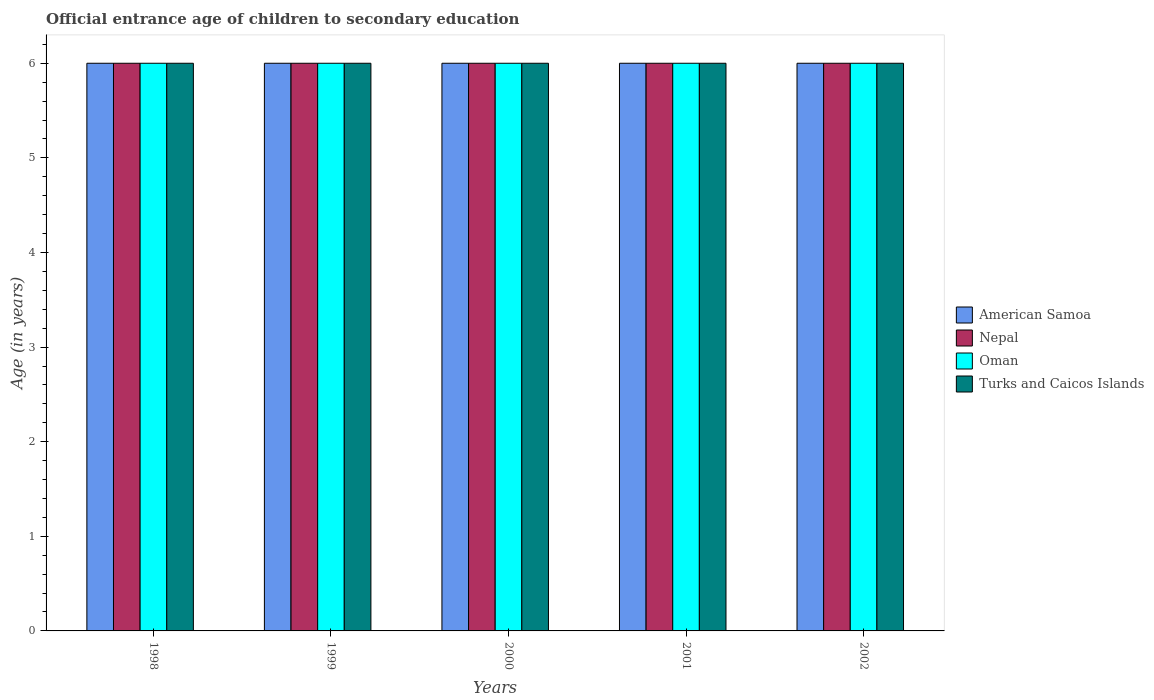How many groups of bars are there?
Make the answer very short. 5. Are the number of bars per tick equal to the number of legend labels?
Offer a terse response. Yes. Are the number of bars on each tick of the X-axis equal?
Provide a succinct answer. Yes. How many bars are there on the 1st tick from the left?
Provide a succinct answer. 4. In how many cases, is the number of bars for a given year not equal to the number of legend labels?
Make the answer very short. 0. What is the secondary school starting age of children in Oman in 1999?
Give a very brief answer. 6. Across all years, what is the maximum secondary school starting age of children in American Samoa?
Keep it short and to the point. 6. Across all years, what is the minimum secondary school starting age of children in American Samoa?
Provide a short and direct response. 6. In which year was the secondary school starting age of children in Turks and Caicos Islands maximum?
Offer a terse response. 1998. In which year was the secondary school starting age of children in Turks and Caicos Islands minimum?
Give a very brief answer. 1998. What is the average secondary school starting age of children in Turks and Caicos Islands per year?
Your response must be concise. 6. In the year 2000, what is the difference between the secondary school starting age of children in American Samoa and secondary school starting age of children in Turks and Caicos Islands?
Ensure brevity in your answer.  0. In how many years, is the secondary school starting age of children in American Samoa greater than 5.8 years?
Your response must be concise. 5. In how many years, is the secondary school starting age of children in American Samoa greater than the average secondary school starting age of children in American Samoa taken over all years?
Your answer should be very brief. 0. What does the 1st bar from the left in 2002 represents?
Ensure brevity in your answer.  American Samoa. What does the 2nd bar from the right in 2000 represents?
Give a very brief answer. Oman. What is the difference between two consecutive major ticks on the Y-axis?
Your answer should be compact. 1. Are the values on the major ticks of Y-axis written in scientific E-notation?
Your answer should be compact. No. Where does the legend appear in the graph?
Your answer should be compact. Center right. How many legend labels are there?
Provide a succinct answer. 4. How are the legend labels stacked?
Your answer should be compact. Vertical. What is the title of the graph?
Make the answer very short. Official entrance age of children to secondary education. What is the label or title of the Y-axis?
Offer a very short reply. Age (in years). What is the Age (in years) of Nepal in 1998?
Offer a very short reply. 6. What is the Age (in years) of Oman in 1998?
Give a very brief answer. 6. What is the Age (in years) of American Samoa in 1999?
Make the answer very short. 6. What is the Age (in years) of Oman in 1999?
Keep it short and to the point. 6. What is the Age (in years) of Turks and Caicos Islands in 1999?
Make the answer very short. 6. What is the Age (in years) of American Samoa in 2000?
Your answer should be compact. 6. What is the Age (in years) in Turks and Caicos Islands in 2000?
Keep it short and to the point. 6. What is the Age (in years) of Nepal in 2001?
Your answer should be compact. 6. What is the Age (in years) of Turks and Caicos Islands in 2001?
Provide a succinct answer. 6. What is the Age (in years) of Nepal in 2002?
Ensure brevity in your answer.  6. Across all years, what is the maximum Age (in years) of Nepal?
Your answer should be very brief. 6. Across all years, what is the maximum Age (in years) in Oman?
Keep it short and to the point. 6. Across all years, what is the minimum Age (in years) of Turks and Caicos Islands?
Provide a short and direct response. 6. What is the total Age (in years) in Nepal in the graph?
Make the answer very short. 30. What is the total Age (in years) in Oman in the graph?
Your answer should be very brief. 30. What is the total Age (in years) in Turks and Caicos Islands in the graph?
Make the answer very short. 30. What is the difference between the Age (in years) of American Samoa in 1998 and that in 1999?
Give a very brief answer. 0. What is the difference between the Age (in years) in Nepal in 1998 and that in 1999?
Keep it short and to the point. 0. What is the difference between the Age (in years) of American Samoa in 1998 and that in 2000?
Provide a short and direct response. 0. What is the difference between the Age (in years) of Nepal in 1998 and that in 2000?
Provide a short and direct response. 0. What is the difference between the Age (in years) of Oman in 1998 and that in 2000?
Give a very brief answer. 0. What is the difference between the Age (in years) of American Samoa in 1998 and that in 2001?
Offer a very short reply. 0. What is the difference between the Age (in years) of Nepal in 1998 and that in 2001?
Provide a succinct answer. 0. What is the difference between the Age (in years) in Oman in 1998 and that in 2001?
Ensure brevity in your answer.  0. What is the difference between the Age (in years) in Turks and Caicos Islands in 1998 and that in 2001?
Provide a succinct answer. 0. What is the difference between the Age (in years) in American Samoa in 1998 and that in 2002?
Provide a succinct answer. 0. What is the difference between the Age (in years) in Nepal in 1998 and that in 2002?
Keep it short and to the point. 0. What is the difference between the Age (in years) of Turks and Caicos Islands in 1998 and that in 2002?
Your answer should be very brief. 0. What is the difference between the Age (in years) in American Samoa in 1999 and that in 2000?
Your answer should be very brief. 0. What is the difference between the Age (in years) in Nepal in 1999 and that in 2000?
Your answer should be compact. 0. What is the difference between the Age (in years) of Oman in 1999 and that in 2000?
Ensure brevity in your answer.  0. What is the difference between the Age (in years) of Nepal in 1999 and that in 2001?
Keep it short and to the point. 0. What is the difference between the Age (in years) of Oman in 1999 and that in 2001?
Keep it short and to the point. 0. What is the difference between the Age (in years) in American Samoa in 1999 and that in 2002?
Offer a terse response. 0. What is the difference between the Age (in years) of Oman in 1999 and that in 2002?
Give a very brief answer. 0. What is the difference between the Age (in years) of Turks and Caicos Islands in 1999 and that in 2002?
Your response must be concise. 0. What is the difference between the Age (in years) of Nepal in 2000 and that in 2001?
Provide a short and direct response. 0. What is the difference between the Age (in years) in American Samoa in 2000 and that in 2002?
Keep it short and to the point. 0. What is the difference between the Age (in years) of Nepal in 2000 and that in 2002?
Your answer should be very brief. 0. What is the difference between the Age (in years) in Oman in 2000 and that in 2002?
Ensure brevity in your answer.  0. What is the difference between the Age (in years) in Turks and Caicos Islands in 2000 and that in 2002?
Your answer should be very brief. 0. What is the difference between the Age (in years) of American Samoa in 2001 and that in 2002?
Your answer should be very brief. 0. What is the difference between the Age (in years) in Nepal in 2001 and that in 2002?
Ensure brevity in your answer.  0. What is the difference between the Age (in years) in American Samoa in 1998 and the Age (in years) in Nepal in 1999?
Offer a very short reply. 0. What is the difference between the Age (in years) in American Samoa in 1998 and the Age (in years) in Oman in 1999?
Your response must be concise. 0. What is the difference between the Age (in years) of American Samoa in 1998 and the Age (in years) of Turks and Caicos Islands in 1999?
Provide a short and direct response. 0. What is the difference between the Age (in years) of Nepal in 1998 and the Age (in years) of Oman in 1999?
Provide a succinct answer. 0. What is the difference between the Age (in years) in American Samoa in 1998 and the Age (in years) in Nepal in 2000?
Offer a very short reply. 0. What is the difference between the Age (in years) in Oman in 1998 and the Age (in years) in Turks and Caicos Islands in 2000?
Provide a succinct answer. 0. What is the difference between the Age (in years) in American Samoa in 1998 and the Age (in years) in Oman in 2001?
Give a very brief answer. 0. What is the difference between the Age (in years) in American Samoa in 1998 and the Age (in years) in Turks and Caicos Islands in 2001?
Ensure brevity in your answer.  0. What is the difference between the Age (in years) in Nepal in 1998 and the Age (in years) in Oman in 2001?
Provide a succinct answer. 0. What is the difference between the Age (in years) in Nepal in 1998 and the Age (in years) in Turks and Caicos Islands in 2001?
Offer a terse response. 0. What is the difference between the Age (in years) of American Samoa in 1998 and the Age (in years) of Oman in 2002?
Make the answer very short. 0. What is the difference between the Age (in years) of American Samoa in 1998 and the Age (in years) of Turks and Caicos Islands in 2002?
Ensure brevity in your answer.  0. What is the difference between the Age (in years) of Nepal in 1998 and the Age (in years) of Turks and Caicos Islands in 2002?
Provide a short and direct response. 0. What is the difference between the Age (in years) of American Samoa in 1999 and the Age (in years) of Oman in 2000?
Provide a succinct answer. 0. What is the difference between the Age (in years) of American Samoa in 1999 and the Age (in years) of Turks and Caicos Islands in 2000?
Your answer should be very brief. 0. What is the difference between the Age (in years) in American Samoa in 1999 and the Age (in years) in Nepal in 2001?
Your answer should be compact. 0. What is the difference between the Age (in years) in American Samoa in 1999 and the Age (in years) in Turks and Caicos Islands in 2001?
Provide a short and direct response. 0. What is the difference between the Age (in years) in Oman in 1999 and the Age (in years) in Turks and Caicos Islands in 2001?
Offer a terse response. 0. What is the difference between the Age (in years) in American Samoa in 1999 and the Age (in years) in Nepal in 2002?
Give a very brief answer. 0. What is the difference between the Age (in years) in American Samoa in 1999 and the Age (in years) in Turks and Caicos Islands in 2002?
Your answer should be very brief. 0. What is the difference between the Age (in years) in Nepal in 1999 and the Age (in years) in Turks and Caicos Islands in 2002?
Make the answer very short. 0. What is the difference between the Age (in years) in American Samoa in 2000 and the Age (in years) in Nepal in 2001?
Your answer should be compact. 0. What is the difference between the Age (in years) in American Samoa in 2000 and the Age (in years) in Oman in 2001?
Provide a short and direct response. 0. What is the difference between the Age (in years) of Nepal in 2000 and the Age (in years) of Oman in 2001?
Keep it short and to the point. 0. What is the difference between the Age (in years) of American Samoa in 2000 and the Age (in years) of Nepal in 2002?
Offer a very short reply. 0. What is the difference between the Age (in years) in American Samoa in 2000 and the Age (in years) in Turks and Caicos Islands in 2002?
Offer a terse response. 0. What is the difference between the Age (in years) in Nepal in 2000 and the Age (in years) in Turks and Caicos Islands in 2002?
Make the answer very short. 0. What is the difference between the Age (in years) of Oman in 2000 and the Age (in years) of Turks and Caicos Islands in 2002?
Ensure brevity in your answer.  0. What is the difference between the Age (in years) in American Samoa in 2001 and the Age (in years) in Nepal in 2002?
Provide a succinct answer. 0. What is the difference between the Age (in years) of American Samoa in 2001 and the Age (in years) of Turks and Caicos Islands in 2002?
Offer a very short reply. 0. What is the difference between the Age (in years) of Oman in 2001 and the Age (in years) of Turks and Caicos Islands in 2002?
Your answer should be compact. 0. What is the average Age (in years) in Nepal per year?
Provide a short and direct response. 6. What is the average Age (in years) in Oman per year?
Your answer should be compact. 6. What is the average Age (in years) in Turks and Caicos Islands per year?
Ensure brevity in your answer.  6. In the year 1998, what is the difference between the Age (in years) in American Samoa and Age (in years) in Nepal?
Make the answer very short. 0. In the year 1998, what is the difference between the Age (in years) in American Samoa and Age (in years) in Turks and Caicos Islands?
Offer a terse response. 0. In the year 1998, what is the difference between the Age (in years) in Nepal and Age (in years) in Oman?
Ensure brevity in your answer.  0. In the year 1998, what is the difference between the Age (in years) in Oman and Age (in years) in Turks and Caicos Islands?
Make the answer very short. 0. In the year 1999, what is the difference between the Age (in years) of Nepal and Age (in years) of Oman?
Give a very brief answer. 0. In the year 1999, what is the difference between the Age (in years) of Nepal and Age (in years) of Turks and Caicos Islands?
Make the answer very short. 0. In the year 1999, what is the difference between the Age (in years) in Oman and Age (in years) in Turks and Caicos Islands?
Provide a short and direct response. 0. In the year 2000, what is the difference between the Age (in years) in American Samoa and Age (in years) in Oman?
Your response must be concise. 0. In the year 2001, what is the difference between the Age (in years) of American Samoa and Age (in years) of Nepal?
Provide a succinct answer. 0. In the year 2001, what is the difference between the Age (in years) in Nepal and Age (in years) in Oman?
Provide a short and direct response. 0. In the year 2001, what is the difference between the Age (in years) in Nepal and Age (in years) in Turks and Caicos Islands?
Your answer should be very brief. 0. In the year 2001, what is the difference between the Age (in years) in Oman and Age (in years) in Turks and Caicos Islands?
Provide a short and direct response. 0. In the year 2002, what is the difference between the Age (in years) of American Samoa and Age (in years) of Nepal?
Provide a succinct answer. 0. In the year 2002, what is the difference between the Age (in years) in American Samoa and Age (in years) in Oman?
Give a very brief answer. 0. In the year 2002, what is the difference between the Age (in years) of Oman and Age (in years) of Turks and Caicos Islands?
Make the answer very short. 0. What is the ratio of the Age (in years) of Nepal in 1998 to that in 1999?
Make the answer very short. 1. What is the ratio of the Age (in years) in Oman in 1998 to that in 1999?
Provide a short and direct response. 1. What is the ratio of the Age (in years) of American Samoa in 1998 to that in 2001?
Your answer should be very brief. 1. What is the ratio of the Age (in years) of American Samoa in 1998 to that in 2002?
Your answer should be very brief. 1. What is the ratio of the Age (in years) of Oman in 1998 to that in 2002?
Ensure brevity in your answer.  1. What is the ratio of the Age (in years) in Turks and Caicos Islands in 1998 to that in 2002?
Make the answer very short. 1. What is the ratio of the Age (in years) in American Samoa in 1999 to that in 2000?
Offer a very short reply. 1. What is the ratio of the Age (in years) of Oman in 1999 to that in 2000?
Offer a very short reply. 1. What is the ratio of the Age (in years) of American Samoa in 1999 to that in 2001?
Your response must be concise. 1. What is the ratio of the Age (in years) in Nepal in 1999 to that in 2001?
Your response must be concise. 1. What is the ratio of the Age (in years) in Turks and Caicos Islands in 1999 to that in 2001?
Ensure brevity in your answer.  1. What is the ratio of the Age (in years) of American Samoa in 1999 to that in 2002?
Make the answer very short. 1. What is the ratio of the Age (in years) in Turks and Caicos Islands in 1999 to that in 2002?
Offer a terse response. 1. What is the ratio of the Age (in years) in American Samoa in 2000 to that in 2001?
Offer a very short reply. 1. What is the ratio of the Age (in years) of Nepal in 2000 to that in 2001?
Provide a succinct answer. 1. What is the ratio of the Age (in years) in Nepal in 2000 to that in 2002?
Offer a very short reply. 1. What is the ratio of the Age (in years) of Oman in 2000 to that in 2002?
Provide a succinct answer. 1. What is the ratio of the Age (in years) in Turks and Caicos Islands in 2000 to that in 2002?
Your answer should be very brief. 1. What is the ratio of the Age (in years) in Oman in 2001 to that in 2002?
Offer a terse response. 1. What is the difference between the highest and the second highest Age (in years) in Oman?
Your answer should be compact. 0. What is the difference between the highest and the lowest Age (in years) in Turks and Caicos Islands?
Make the answer very short. 0. 